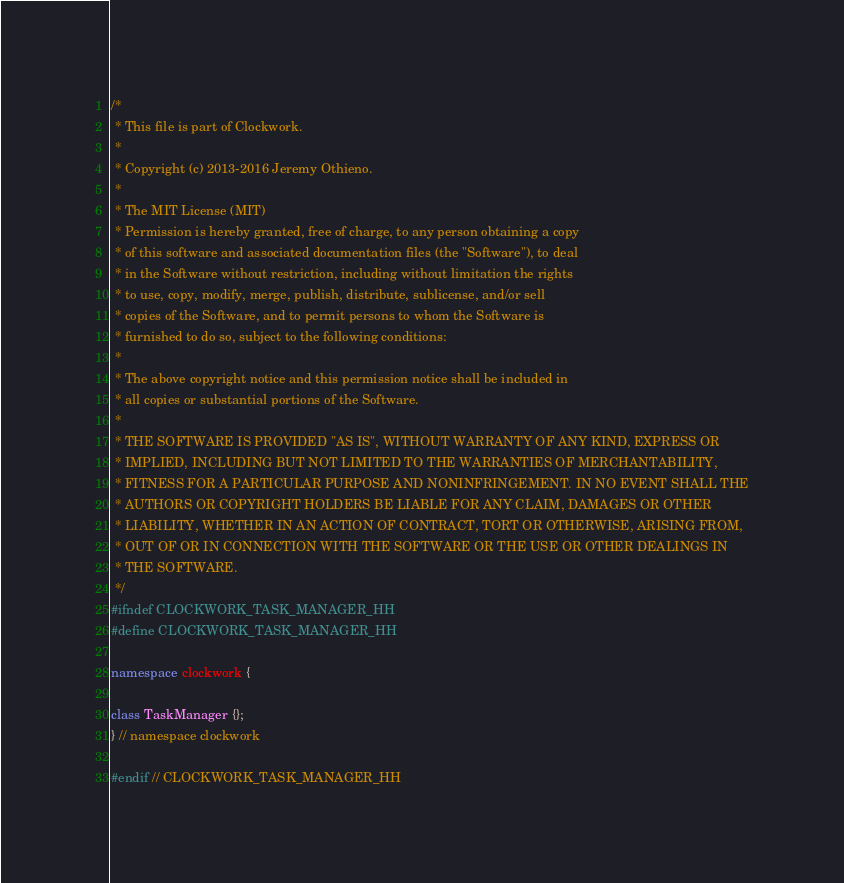<code> <loc_0><loc_0><loc_500><loc_500><_C++_>/*
 * This file is part of Clockwork.
 *
 * Copyright (c) 2013-2016 Jeremy Othieno.
 *
 * The MIT License (MIT)
 * Permission is hereby granted, free of charge, to any person obtaining a copy
 * of this software and associated documentation files (the "Software"), to deal
 * in the Software without restriction, including without limitation the rights
 * to use, copy, modify, merge, publish, distribute, sublicense, and/or sell
 * copies of the Software, and to permit persons to whom the Software is
 * furnished to do so, subject to the following conditions:
 *
 * The above copyright notice and this permission notice shall be included in
 * all copies or substantial portions of the Software.
 *
 * THE SOFTWARE IS PROVIDED "AS IS", WITHOUT WARRANTY OF ANY KIND, EXPRESS OR
 * IMPLIED, INCLUDING BUT NOT LIMITED TO THE WARRANTIES OF MERCHANTABILITY,
 * FITNESS FOR A PARTICULAR PURPOSE AND NONINFRINGEMENT. IN NO EVENT SHALL THE
 * AUTHORS OR COPYRIGHT HOLDERS BE LIABLE FOR ANY CLAIM, DAMAGES OR OTHER
 * LIABILITY, WHETHER IN AN ACTION OF CONTRACT, TORT OR OTHERWISE, ARISING FROM,
 * OUT OF OR IN CONNECTION WITH THE SOFTWARE OR THE USE OR OTHER DEALINGS IN
 * THE SOFTWARE.
 */
#ifndef CLOCKWORK_TASK_MANAGER_HH
#define CLOCKWORK_TASK_MANAGER_HH

namespace clockwork {

class TaskManager {};
} // namespace clockwork

#endif // CLOCKWORK_TASK_MANAGER_HH
</code> 